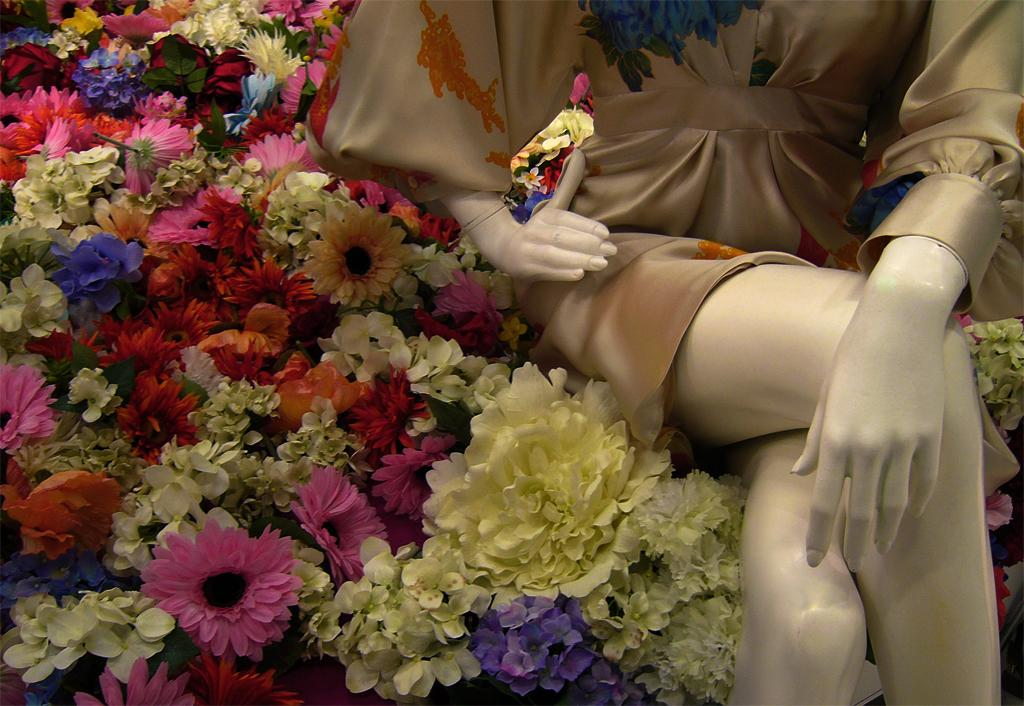What types of plants can be seen in the image? There are different colorful flowers in the image. What other object is present in the image besides the flowers? There is a statue of a lady in the image. What is the name of the son of the lady depicted in the statue? There is no son mentioned or depicted in the image, as it only features a statue of a lady and colorful flowers. 